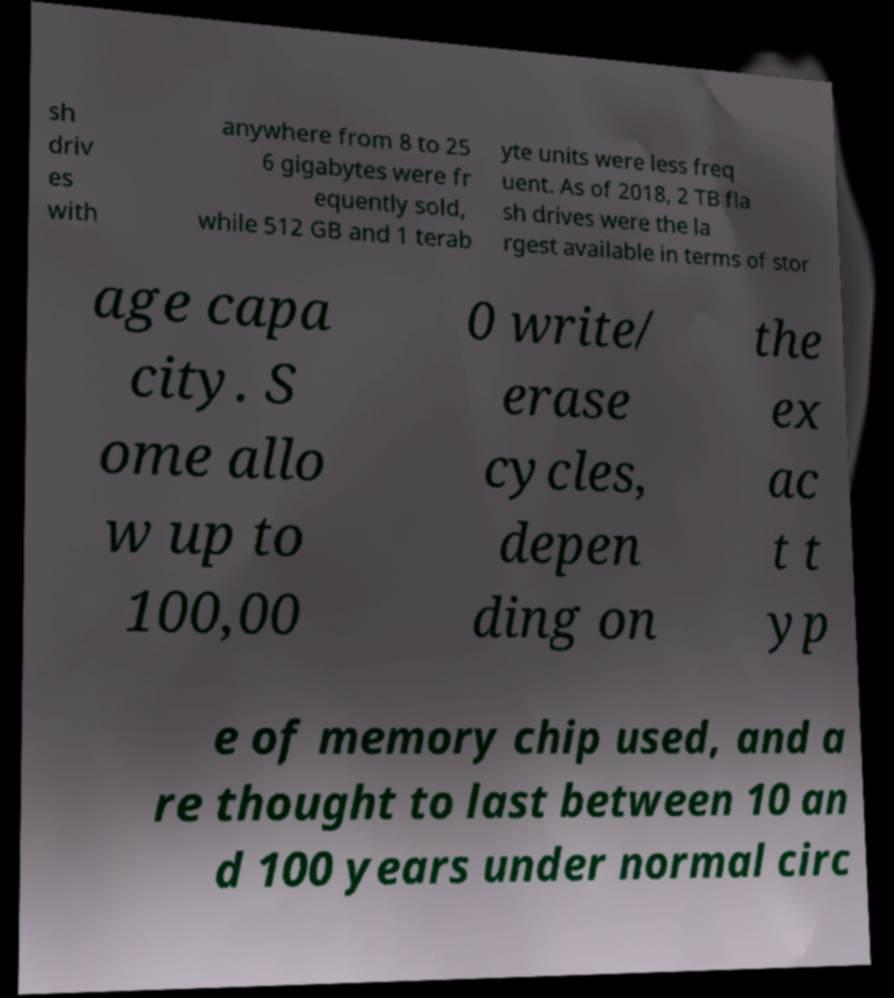For documentation purposes, I need the text within this image transcribed. Could you provide that? sh driv es with anywhere from 8 to 25 6 gigabytes were fr equently sold, while 512 GB and 1 terab yte units were less freq uent. As of 2018, 2 TB fla sh drives were the la rgest available in terms of stor age capa city. S ome allo w up to 100,00 0 write/ erase cycles, depen ding on the ex ac t t yp e of memory chip used, and a re thought to last between 10 an d 100 years under normal circ 